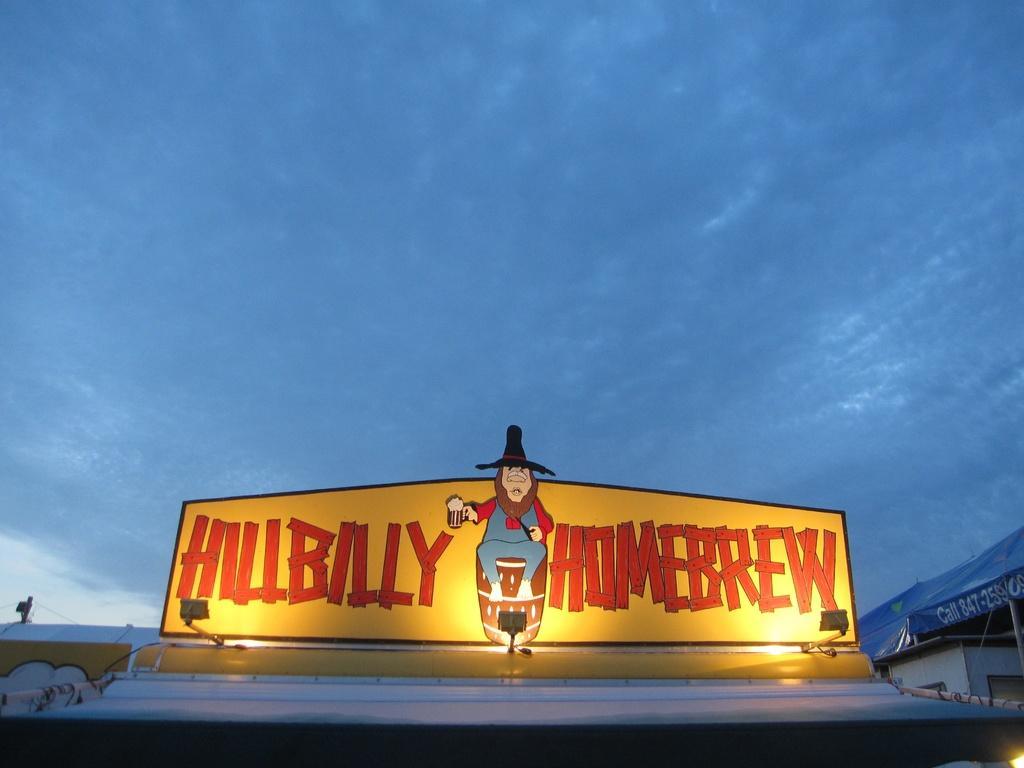Please provide a concise description of this image. As we can see in the image there are buildings, banner, sky and clouds. 